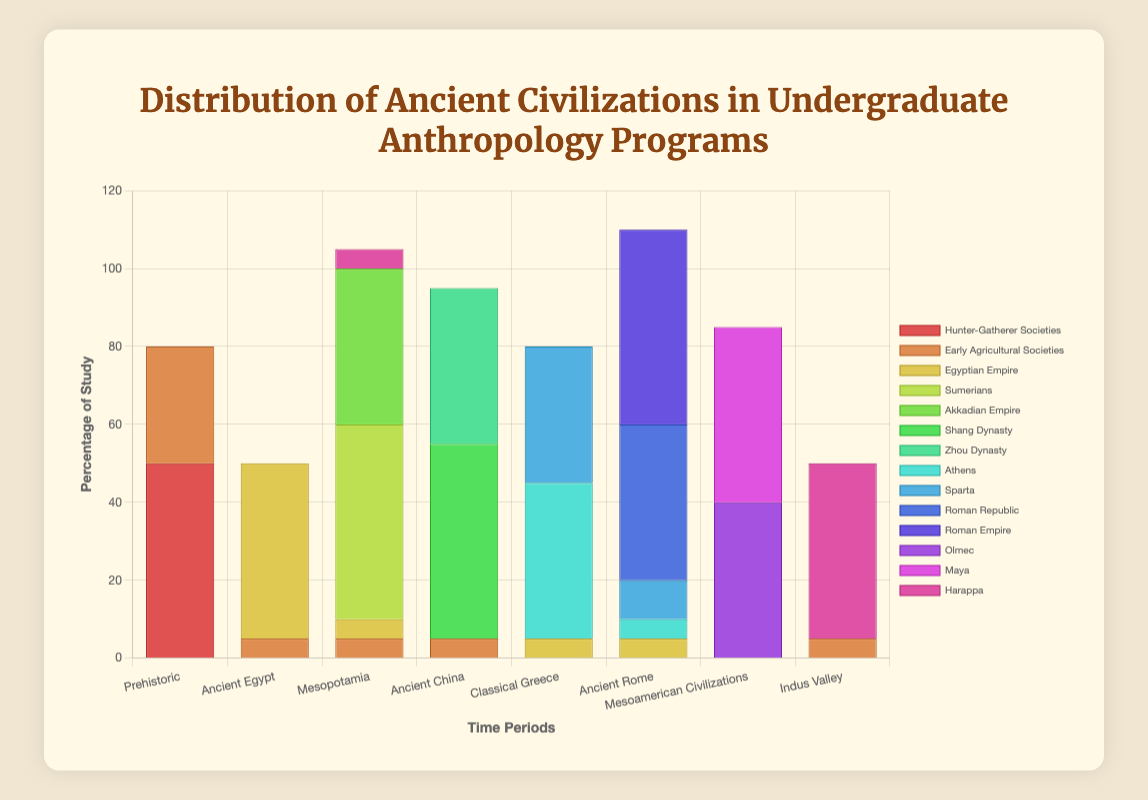Which ancient civilization overwhelmingly dominates the study of the "Prehistoric" time period? The chart shows that "Hunter-Gatherer Societies" account for nearly the entire percentage in the "Prehistoric" time period, with a value of 50%, while "Early Agricultural Societies" contribute the other 30%. This indicates that "Hunter-Gatherer Societies" dominate this period.
Answer: Hunter-Gatherer Societies Which civilization is studied equally across both "Ancient Egypt" and "Ancient Rome"? By examining the height of the bars, it is apparent that the "Egyptian Empire" contributes to 5% in both "Ancient Egypt" and "Ancient Rome". This equal contribution signifies that it’s studied equally in both time periods.
Answer: Egyptian Empire What is the total percentage of study for civilizations in the "Mesopotamia" time period? Summing the heights of the bars in "Mesopotamia", we add 50% (Sumerians) + 40% (Akkadian Empire) + 5% (Egyptian Empire) + 5% (Early Agricultural Societies) = 100%.
Answer: 100 Which time period has the most evenly distributed study among different civilizations? By comparing the heights of bars for each time period, it's evident that "Classical Greece" has the most evenly distributed study contributions among "Athens" (40%) and "Sparta" (35%). Both values are close, indicating an even distribution.
Answer: Classical Greece In the "Ancient China" time period, which civilization's study percentage is higher: the Shang Dynasty or the Zhou Dynasty? Comparing the heights of the bars in "Ancient China", the bar for "Shang Dynasty" is higher at 50% compared to "Zhou Dynasty" which is at 40%.
Answer: Shang Dynasty How much more study is dedicated to the "Roman Empire" in "Ancient Rome" compared to the "Roman Republic"? The chart exhibits the "Roman Empire" with a 50% study in "Ancient Rome" versus the "Roman Republic" with 40%. The difference is 50% - 40% = 10%.
Answer: 10% What is the total percentage of study dedicated to civilizations in the "Mesoamerican Civilizations" time period? Summing the heights of the bars in "Mesoamerican Civilizations", we have 40% (Olmec) + 45% (Maya) = 85%.
Answer: 85 Which civilization has the highest percentage of study in the "Indus Valley" time period? Looking at the bars for "Indus Valley," the highest bar belongs to "Harappa", which is 45%. This is the maximum percentage for this time period.
Answer: Harappa Is the study of "Early Agricultural Societies" more prevalent in "Ancient Egypt" or in the "Indus Valley" time period? Comparing the heights of the bars in "Ancient Egypt" (5%) and "Indus Valley" (5%), they are equal, signifying equal prevalence in both time periods.
Answer: Equal 